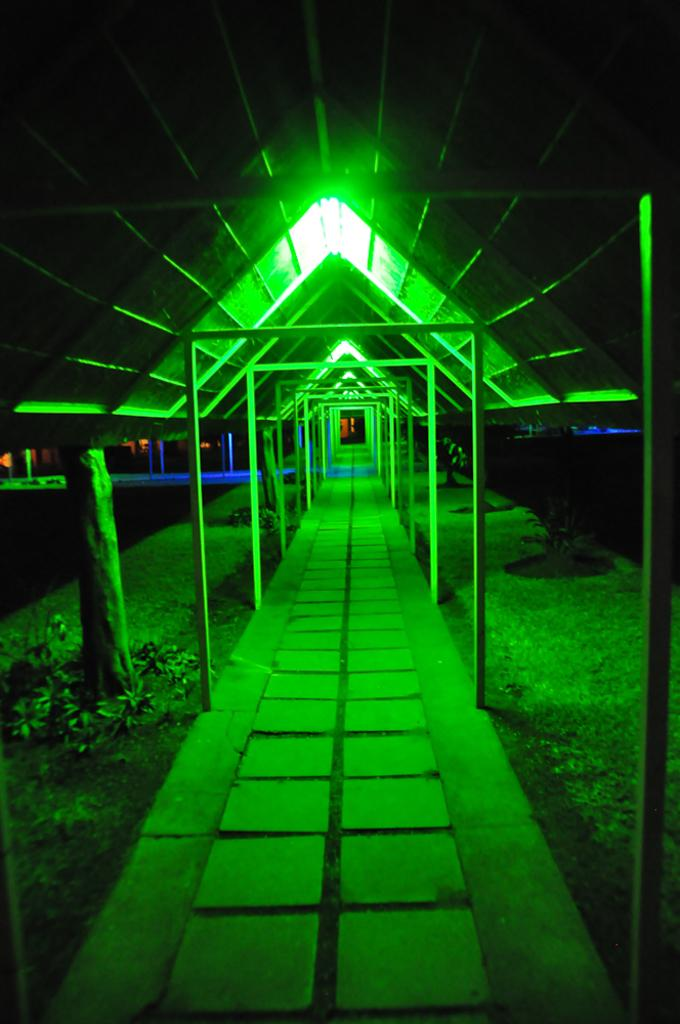What is located at the top of the image? There are lights at the top of the image. What structure might the lights be associated with? The lights are likely to be associated with a shed. What can be seen at the bottom of the image? There is a way visible at the bottom of the image. Can you read the verse written in chalk on the face of the person in the image? There is no person or verse written in chalk present in the image. What type of facial expression does the person have in the image? There is no person present in the image, so it is not possible to describe their facial expression. 